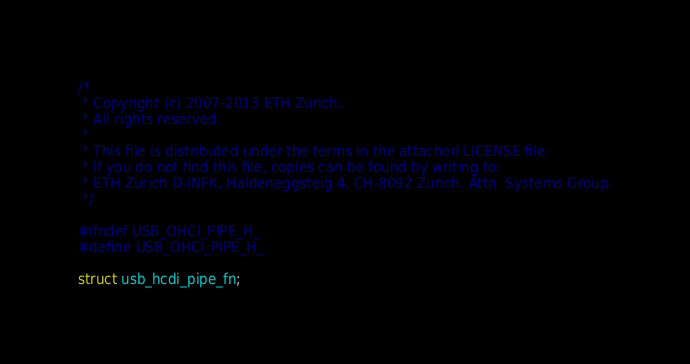<code> <loc_0><loc_0><loc_500><loc_500><_C_>/*
 * Copyright (c) 2007-2013 ETH Zurich.
 * All rights reserved.
 *
 * This file is distributed under the terms in the attached LICENSE file.
 * If you do not find this file, copies can be found by writing to:
 * ETH Zurich D-INFK, Haldeneggsteig 4, CH-8092 Zurich. Attn: Systems Group.
 */

#ifndef USB_OHCI_PIPE_H_
#define USB_OHCI_PIPE_H_

struct usb_hcdi_pipe_fn;
</code> 